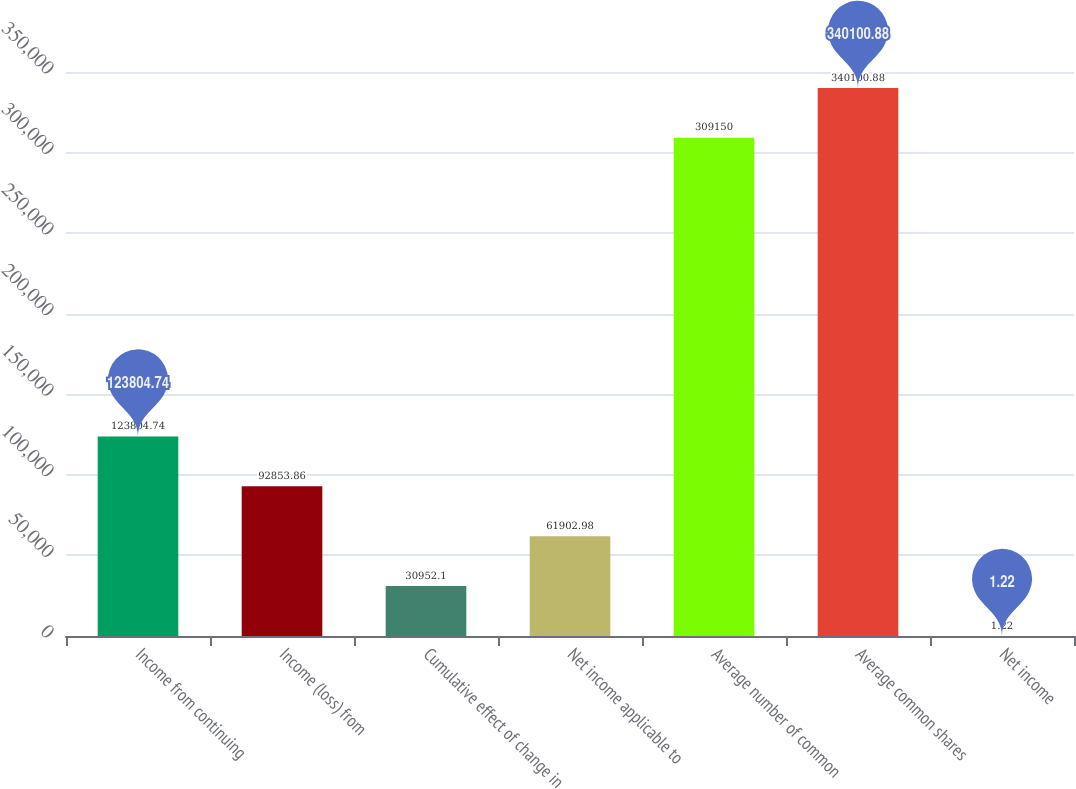Convert chart to OTSL. <chart><loc_0><loc_0><loc_500><loc_500><bar_chart><fcel>Income from continuing<fcel>Income (loss) from<fcel>Cumulative effect of change in<fcel>Net income applicable to<fcel>Average number of common<fcel>Average common shares<fcel>Net income<nl><fcel>123805<fcel>92853.9<fcel>30952.1<fcel>61903<fcel>309150<fcel>340101<fcel>1.22<nl></chart> 